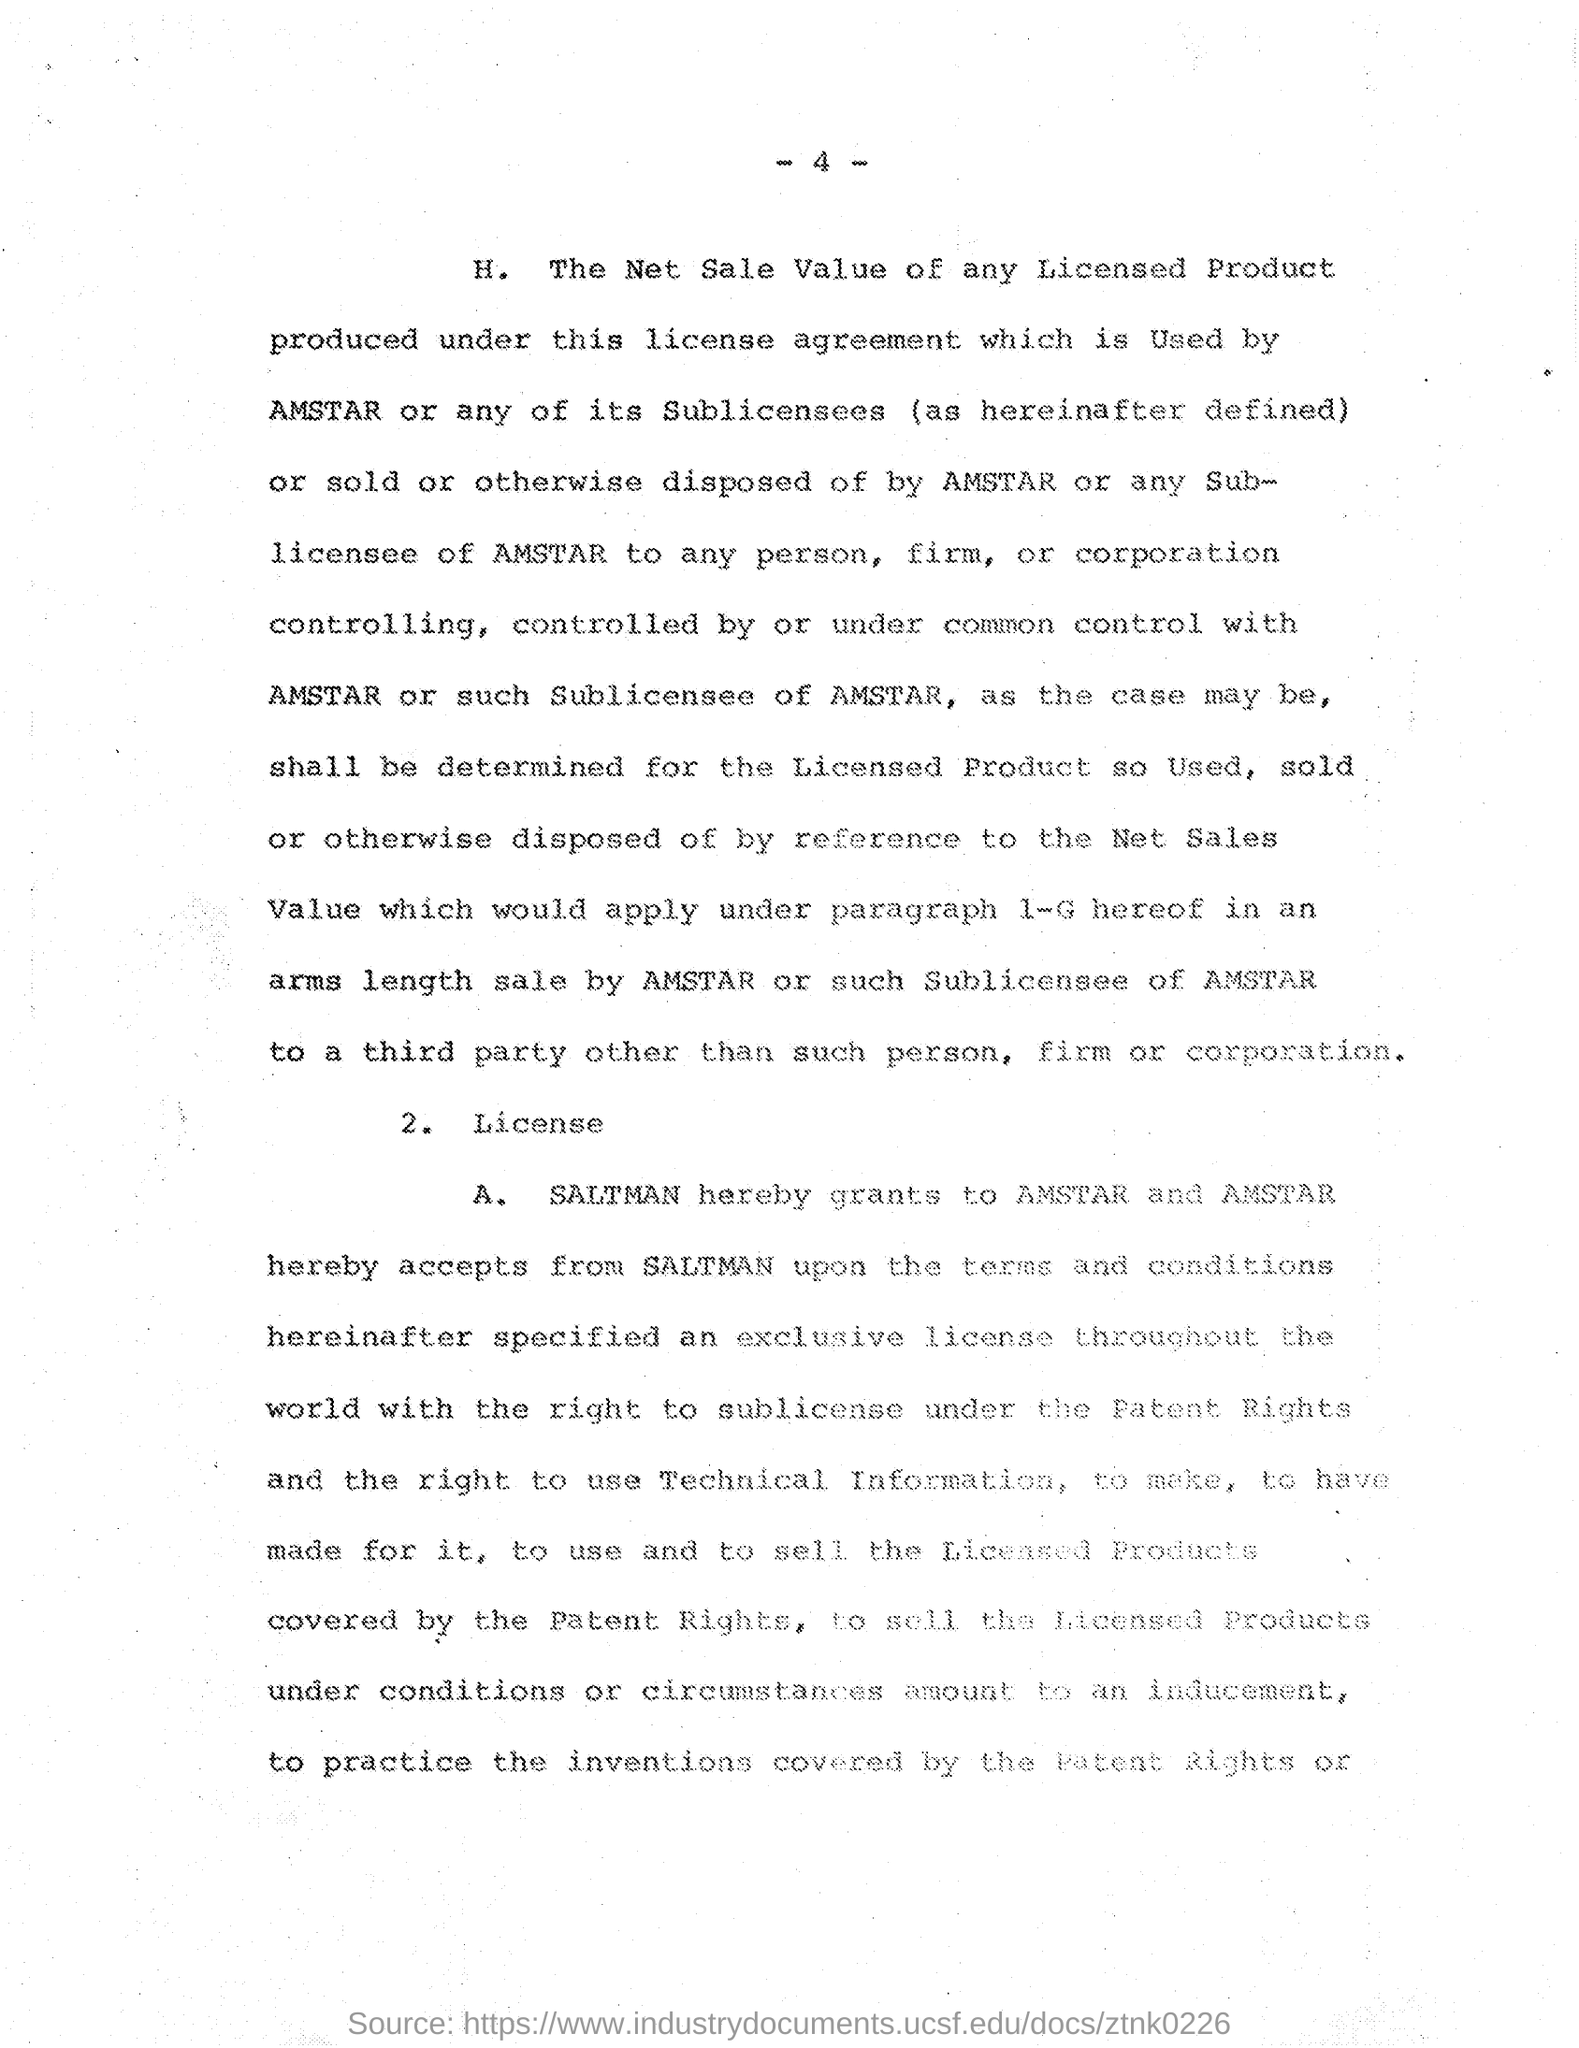What is the Page Number?
Make the answer very short. 4. 